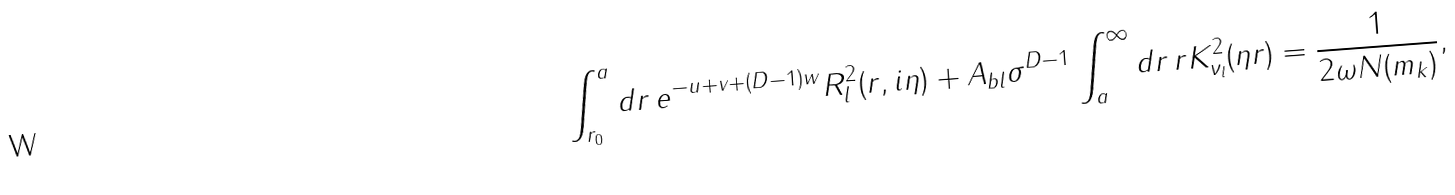Convert formula to latex. <formula><loc_0><loc_0><loc_500><loc_500>\int _ { r _ { 0 } } ^ { a } d r \, e ^ { - u + v + ( D - 1 ) w } R _ { l } ^ { 2 } ( r , i \eta ) + A _ { b l } \sigma ^ { D - 1 } \int _ { a } ^ { \infty } d r \, r K _ { \nu _ { l } } ^ { 2 } ( \eta r ) = \frac { 1 } { 2 \omega N ( m _ { k } ) } ,</formula> 